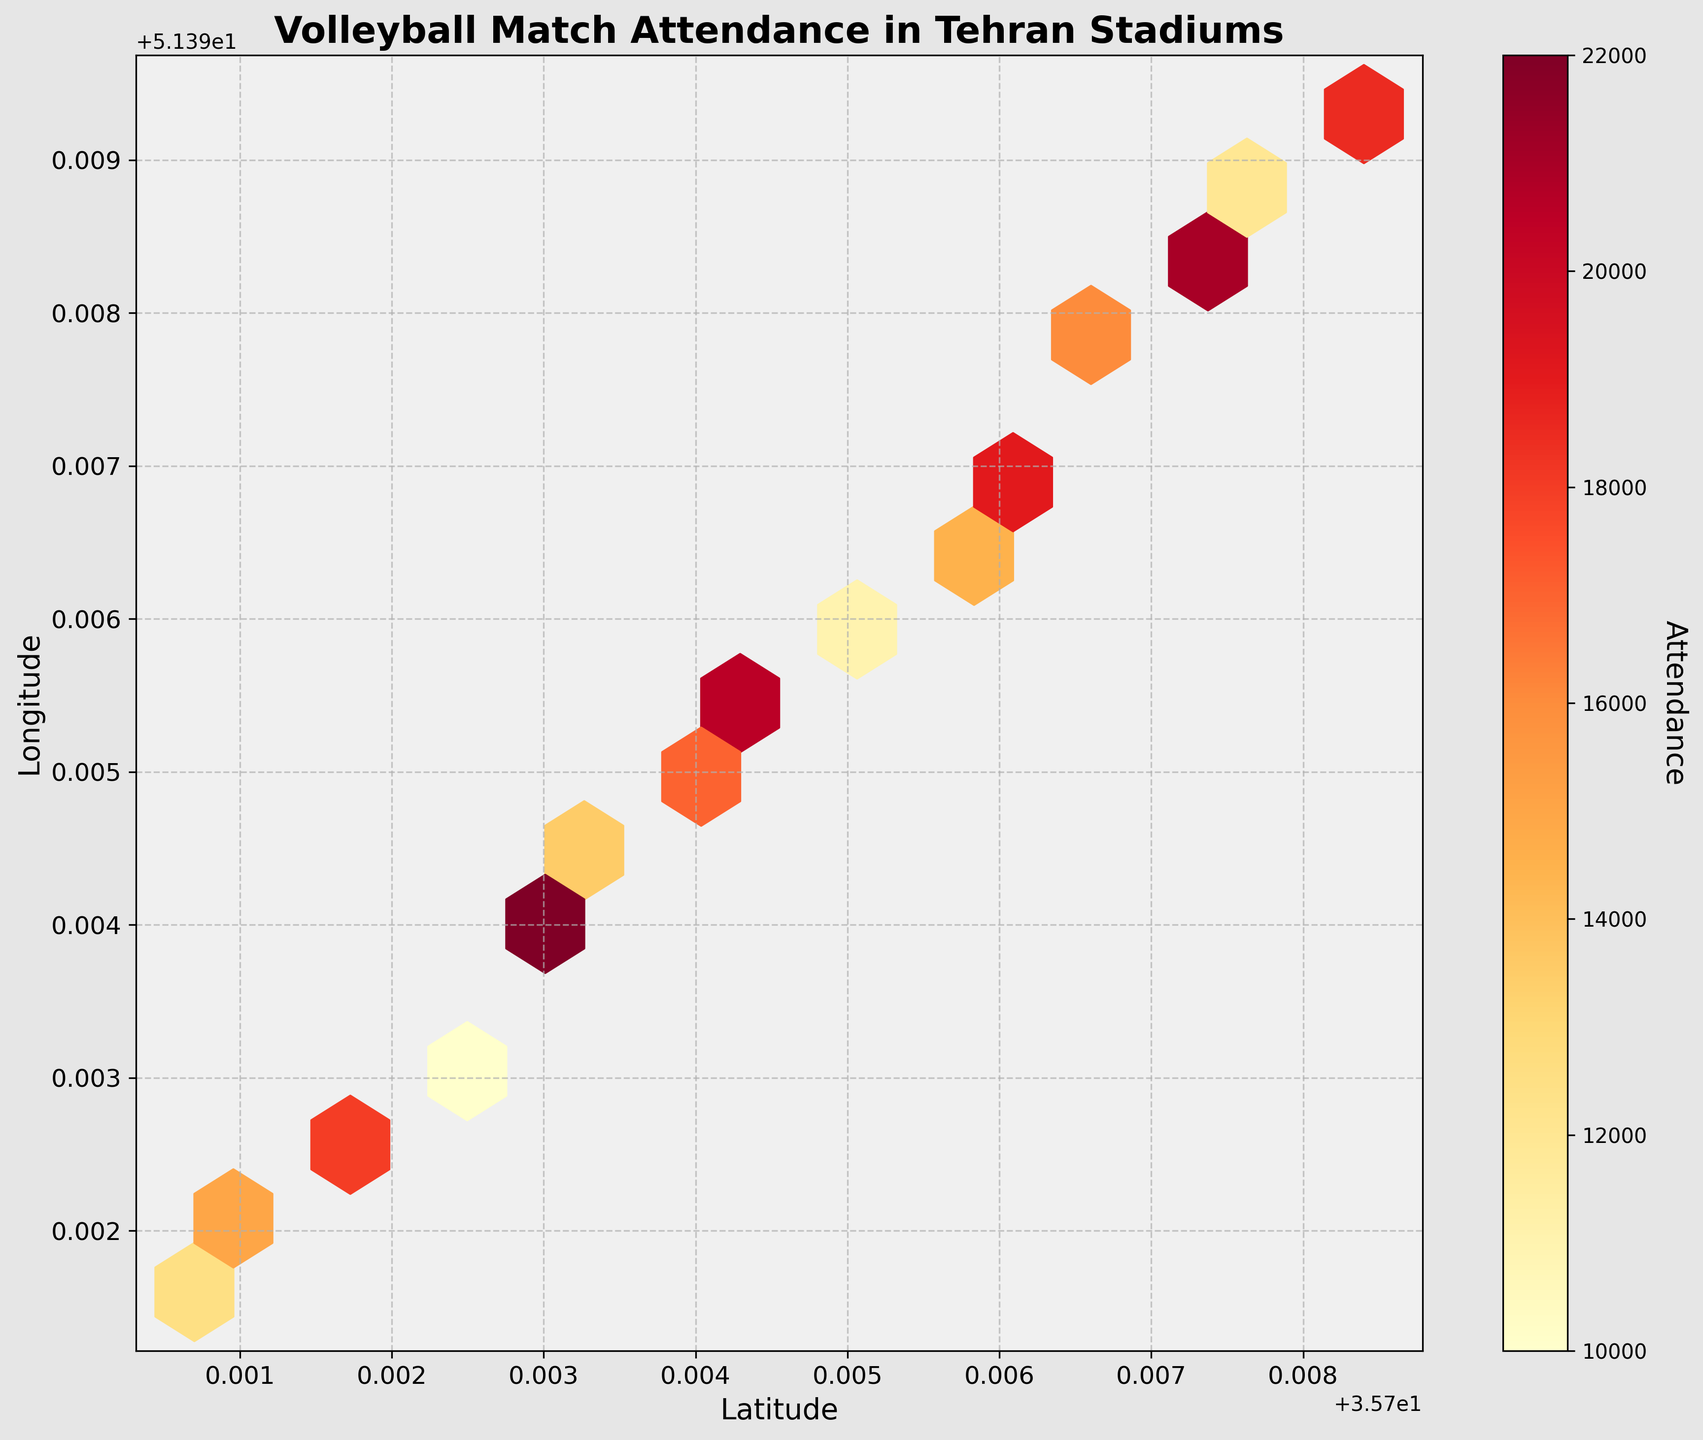What is the title of the hexbin plot? The title is located at the top of the plot and it describes what the hexbin plot is about. Reading it directly will give us the answer.
Answer: Volleyball Match Attendance in Tehran Stadiums What do the colors in the hexbin plot represent? The color bar on the side of the plot indicates that the colors represent different attendance numbers. Darker colors typically represent higher attendance values, and lighter colors indicate lower values.
Answer: Attendance How are the latitude and longitude represented on the hexbin plot? The latitude and longitude are labeled on the x-axis and y-axis respectively. The x-axis is labeled 'Latitude' and the y-axis is labeled 'Longitude'.
Answer: Latitude on the x-axis and Longitude on the y-axis Which location had the highest attendance, according to the plot? By observing the darkest bin in the hexbin plot, we can determine the location with the highest attendance. This bin corresponds to the coordinates around (35.7029, 51.3938).
Answer: Approx. at (35.7029, 51.3938) What is the range of values shown on the color bar? The color bar beside the plot, labeled 'Attendance,' shows the range from the minimum to the maximum attendance. The lowest value is 10,000 and the highest is 22,000.
Answer: 10,000 to 22,000 What longitude shows the densest attendance distribution around latitudes 35.7034 to 35.7040? By observing the density of hexagons parallel to the latitude lines from 35.7034 to 35.7040, we see a dense distribution around longitude 51.3943 to 51.3949.
Answer: 51.3943 to 51.3949 On average, how does the attendance compare between the northern and southern points in the plot? To find the average attendance, sum the values of the attendance at the northern coordinates (higher latitude) and southern coordinates (lower latitude) and compare them. Observing the color density: northern points, around 35.7073 to 35.7084, show darker colors on average compared to southern points, around 35.7007 to 35.7023.
Answer: Higher in the northern points If the hexbin plot was divided vertically at the midpoint of the longitude range, which half would show a higher overall attendance? By approximately dividing the plot at the midpoint of the longitude values (around 51.3950), we observe which half has darker and more bins. The eastern half (right of 51.3950) shows more darker bins, indicating higher overall attendance.
Answer: Eastern half What color is associated with an attendance of approximately 15,000? By observing the color bar and matching the color gradient, the color around the 15,000 mark is a lighter orange shade.
Answer: Lighter orange How does attendance vary with latitude in this plot? Observing the plot, higher attendance (darker colors) are more evident at higher latitudes (around 35.7029, 35.7045, 35.7073), whereas the lower latitudes have lighter colors, indicating a variation where attendance increases with latitude.
Answer: Increases with latitude 